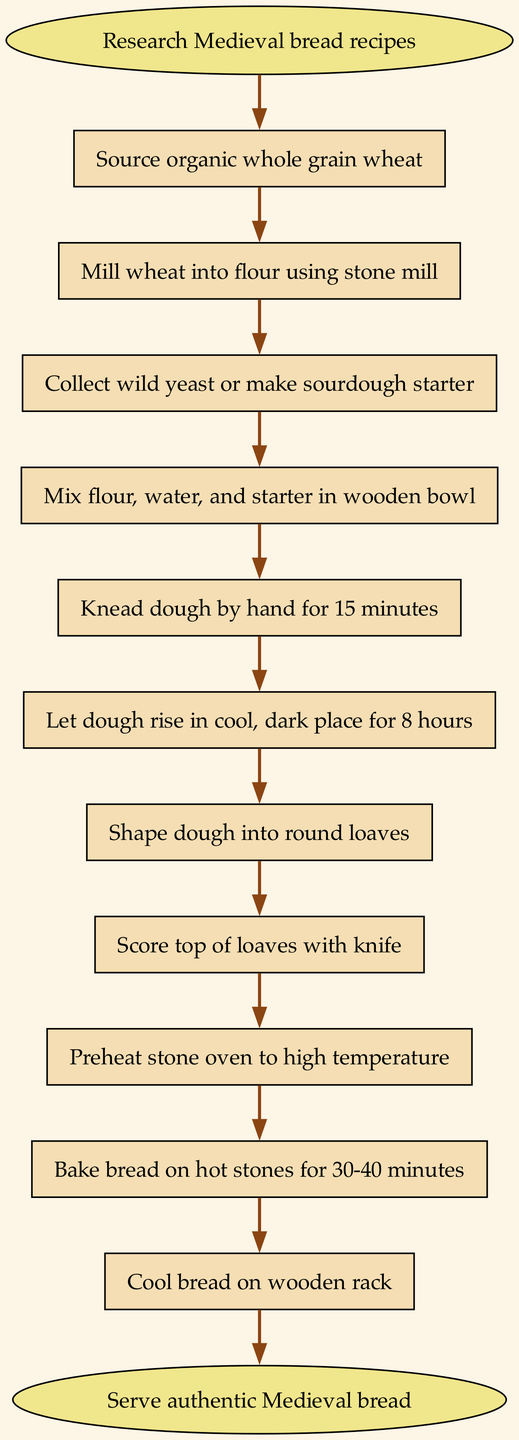What is the first step in creating Medieval bread? The diagram indicates that the first step is to "Research Medieval bread recipes," which is the first node following the start node.
Answer: Research Medieval bread recipes How many steps are in the process? By counting the individual steps listed in the diagram, there are 11 steps in total before reaching the end.
Answer: 11 What is the last action before serving the bread? The last action listed before serving the bread is "Cool bread on wooden rack," which is the final step just before the end node.
Answer: Cool bread on wooden rack Which ingredient is mentioned for making the bread? The diagram mentions "organic whole grain wheat" as the primary ingredient that needs to be sourced at the beginning of the process.
Answer: organic whole grain wheat How long should the dough rise? The diagram specifies that the dough needs to rise for "8 hours," which is indicated in one of the process steps.
Answer: 8 hours What is the relationship between "Let dough rise" and "Shape dough into round loaves"? "Let dough rise" is a prerequisite step that must be completed before proceeding to "Shape dough into round loaves," indicating a sequential relationship.
Answer: Sequential What must be done to prepare the oven? In the process, the diagram states that you need to "Preheat stone oven to high temperature," indicating the preparation required for the baking stage.
Answer: Preheat stone oven to high temperature What action follows after mixing the ingredients? After mixing flour, water, and starter in a wooden bowl, the next action specified in the diagram is to "Knead dough by hand for 15 minutes," indicating the next step in the flow.
Answer: Knead dough by hand for 15 minutes Is “Score top of loaves with knife” a final step? No, according to the diagram, "Score top of loaves with knife" occurs before baking and is not a final step in the process. The final step is "Cool bread on wooden rack."
Answer: No 